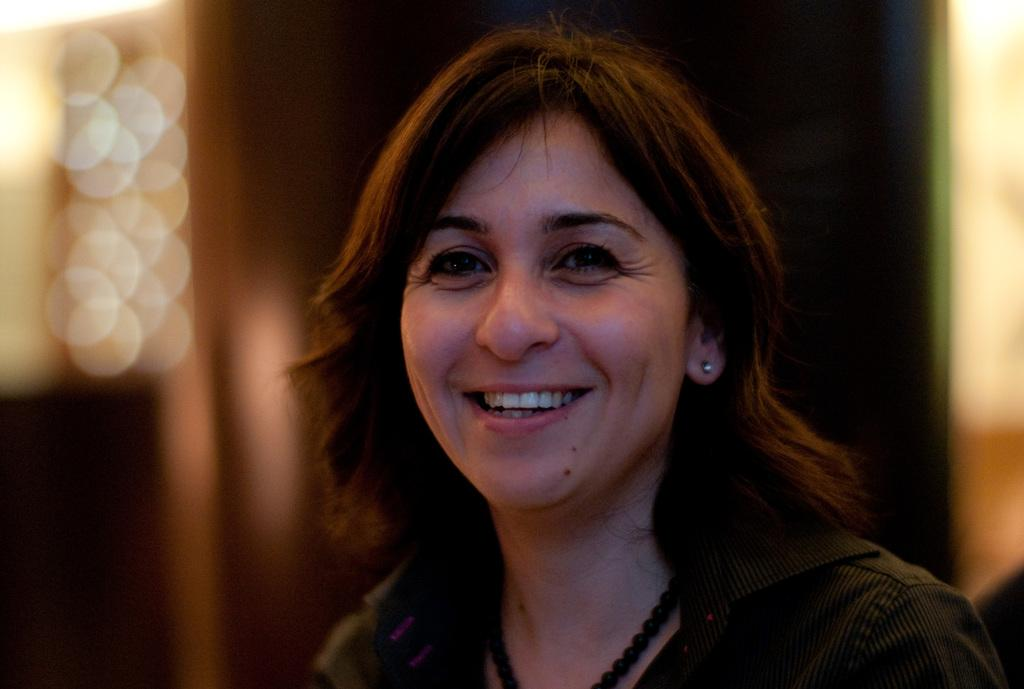Who is present in the image? There is a woman in the image. What expression does the woman have? A: The woman is smiling. Can you describe the background of the image? The background of the image is blurry. Can you describe the river flowing in the background of the image? There is no river present in the image; the background is blurry. 